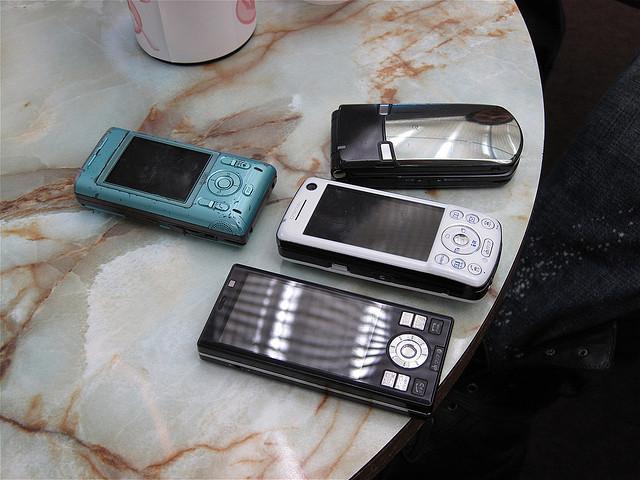What is decade are the phones most likely from?
Make your selection from the four choices given to correctly answer the question.
Options: 2010's, 2020's, 1990's, 1970's. 1990's. 